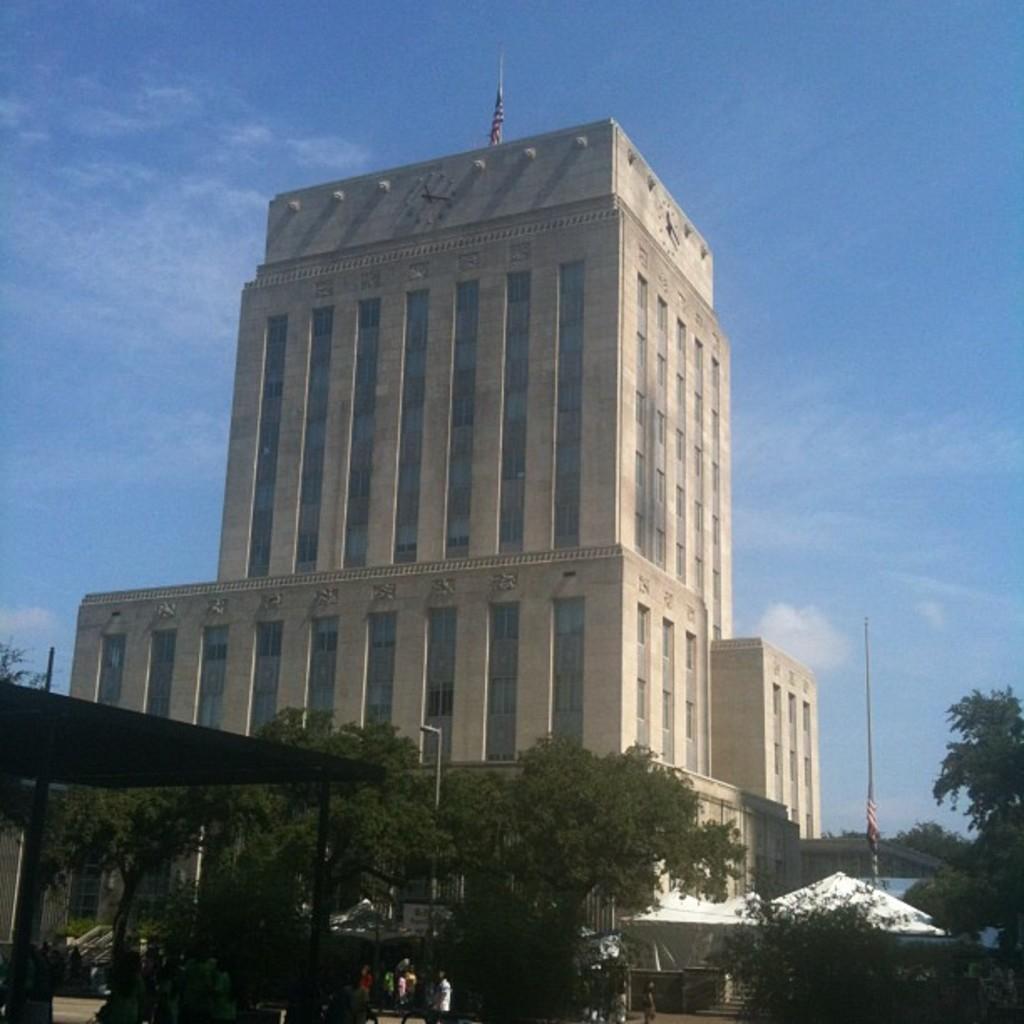Can you describe this image briefly? In this image I can see a multi story building in the center of the image. At the top of the image I can see the sky. At the bottom of the image I can see a shed, trees and some people standing.  